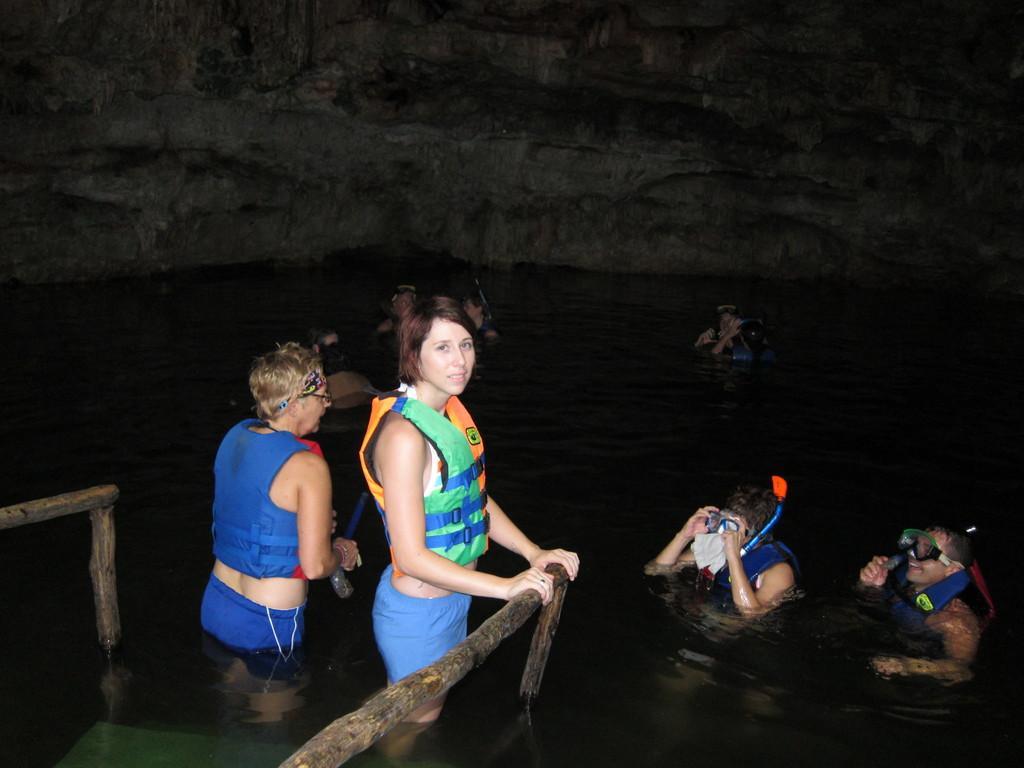Can you describe this image briefly? In this picture I can see 2 women who are standing in the front and the woman on the right is holding a wooden pole and I see another wooden pole on the left side of this image. In the middle of this picture, I see the water in which there are few persons. In the background I see the rock. 